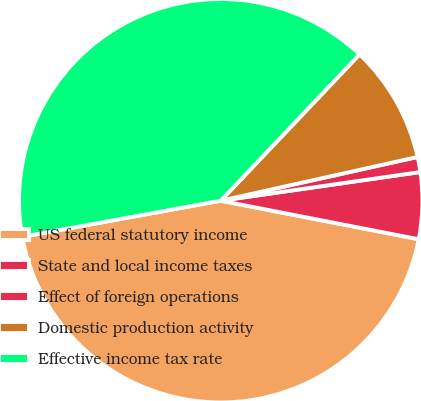Convert chart to OTSL. <chart><loc_0><loc_0><loc_500><loc_500><pie_chart><fcel>US federal statutory income<fcel>State and local income taxes<fcel>Effect of foreign operations<fcel>Domestic production activity<fcel>Effective income tax rate<nl><fcel>44.07%<fcel>5.33%<fcel>1.21%<fcel>9.44%<fcel>39.95%<nl></chart> 